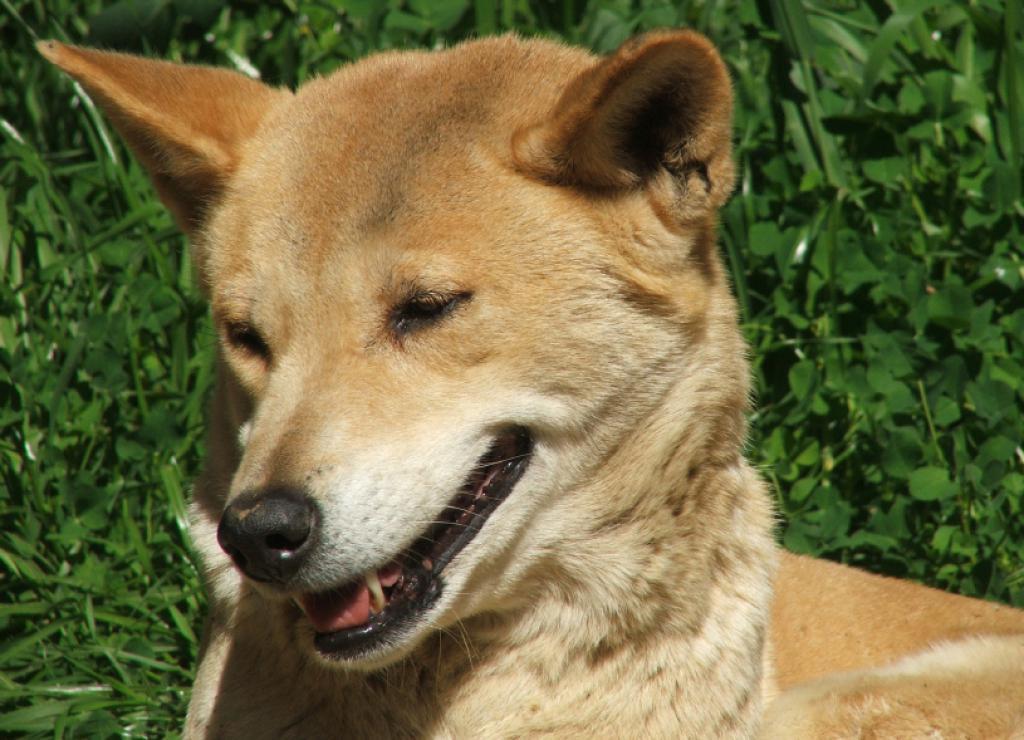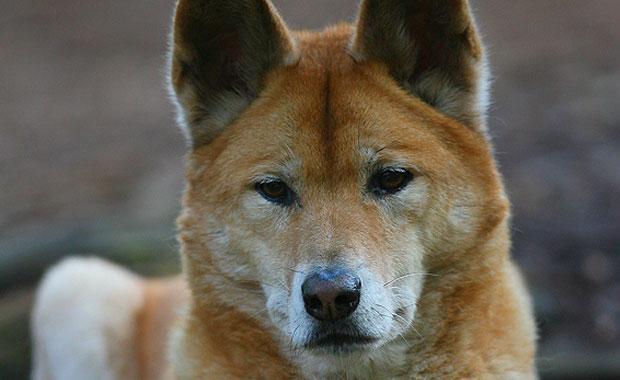The first image is the image on the left, the second image is the image on the right. For the images shown, is this caption "One of the images contains at least two dogs." true? Answer yes or no. No. 